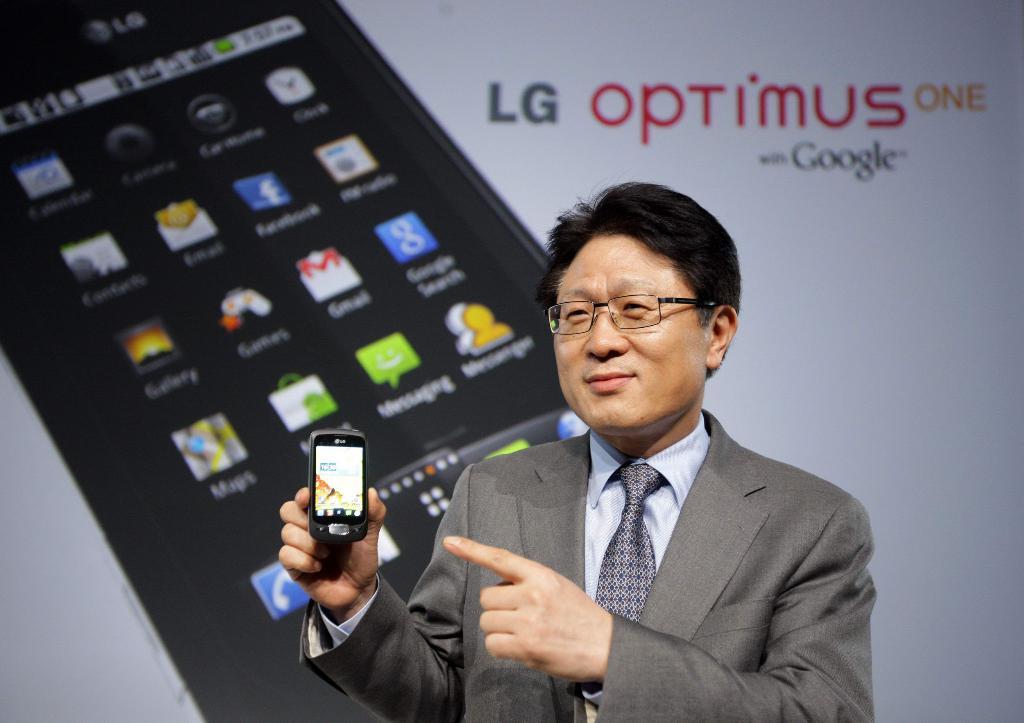What phone model is being featured?
Your response must be concise. Lg optimus one. 